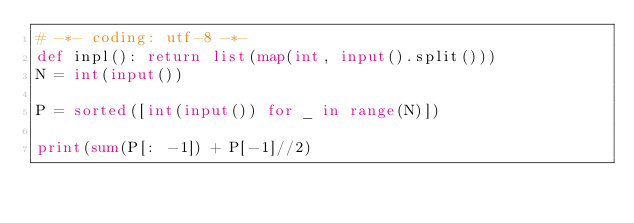<code> <loc_0><loc_0><loc_500><loc_500><_Python_># -*- coding: utf-8 -*-
def inpl(): return list(map(int, input().split()))
N = int(input())

P = sorted([int(input()) for _ in range(N)])

print(sum(P[: -1]) + P[-1]//2)</code> 